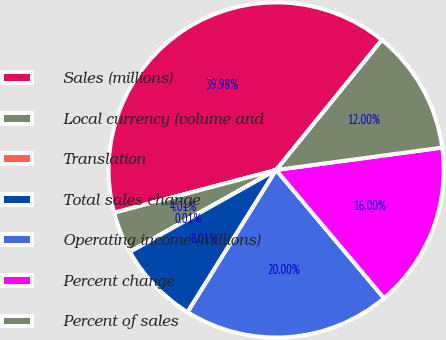Convert chart. <chart><loc_0><loc_0><loc_500><loc_500><pie_chart><fcel>Sales (millions)<fcel>Local currency (volume and<fcel>Translation<fcel>Total sales change<fcel>Operating income (millions)<fcel>Percent change<fcel>Percent of sales<nl><fcel>39.98%<fcel>4.01%<fcel>0.01%<fcel>8.01%<fcel>20.0%<fcel>16.0%<fcel>12.0%<nl></chart> 